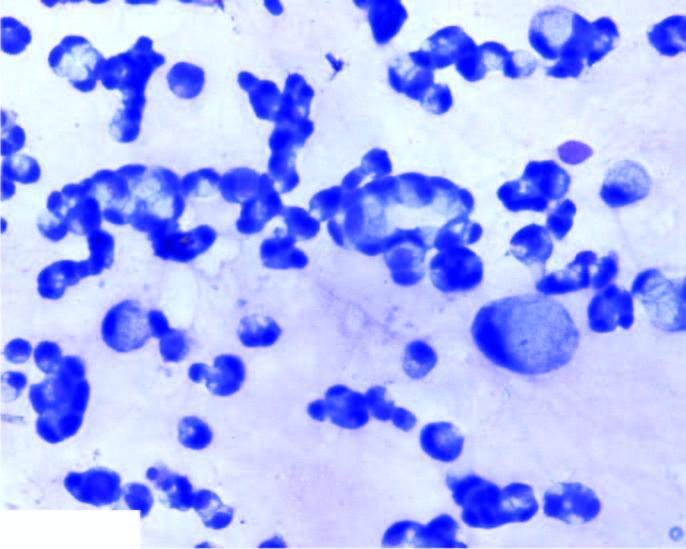how is the number there of malignant cells scattered singly or in small clusters having characteristic cytoplasmic vacuoles, nuclear hyperchromasia and prominent nucleoli?
Answer the question using a single word or phrase. Large 